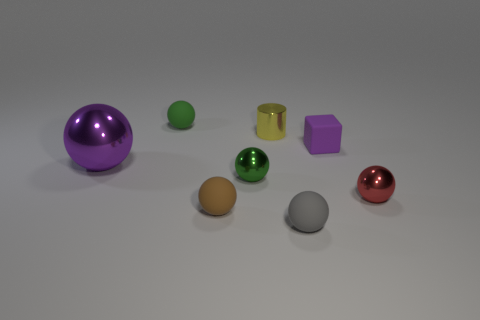There is a purple object right of the green thing that is left of the brown sphere; what is its size?
Give a very brief answer. Small. What number of tiny things are either yellow cylinders or purple rubber cubes?
Give a very brief answer. 2. How big is the metal thing that is behind the metallic ball behind the small green ball in front of the tiny yellow thing?
Give a very brief answer. Small. Is there any other thing of the same color as the metal cylinder?
Your answer should be compact. No. The purple thing on the left side of the green shiny ball that is right of the tiny green object that is behind the big metallic object is made of what material?
Offer a very short reply. Metal. Is the shape of the tiny red object the same as the brown rubber thing?
Provide a succinct answer. Yes. What number of balls are both behind the yellow shiny cylinder and in front of the large purple object?
Offer a terse response. 0. There is a metal sphere that is to the left of the tiny green object that is behind the yellow cylinder; what color is it?
Keep it short and to the point. Purple. Are there an equal number of brown balls behind the tiny yellow cylinder and purple metal objects?
Provide a short and direct response. No. How many green balls are in front of the matte ball behind the ball to the right of the tiny gray rubber object?
Offer a very short reply. 1. 